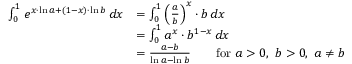<formula> <loc_0><loc_0><loc_500><loc_500>{ \begin{array} { r l } { \int _ { 0 } ^ { 1 } e ^ { x \cdot \ln a + ( 1 - x ) \cdot \ln b } \, d x } & { = \int _ { 0 } ^ { 1 } \left ( { \frac { a } { b } } \right ) ^ { x } \cdot b \, d x } \\ & { = \int _ { 0 } ^ { 1 } a ^ { x } \cdot b ^ { 1 - x } \, d x } \\ & { = { \frac { a - b } { \ln a - \ln b } } \quad { f o r } a > 0 , \ b > 0 , \ a \neq b } \end{array} }</formula> 